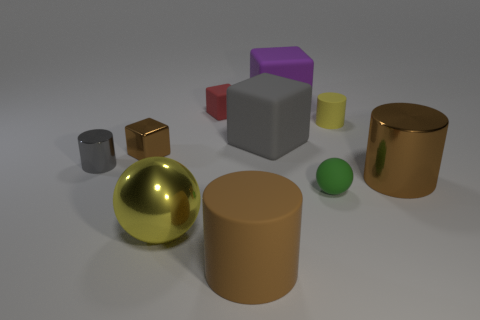Are there more brown shiny blocks right of the large yellow metallic ball than big rubber things behind the yellow matte cylinder?
Offer a very short reply. No. What is the material of the tiny brown thing?
Keep it short and to the point. Metal. There is a brown metal thing to the left of the small cube to the right of the block left of the large yellow metal object; what is its shape?
Keep it short and to the point. Cube. How many other things are the same material as the large purple cube?
Offer a terse response. 5. Are the gray object left of the big matte cylinder and the cylinder that is in front of the brown metallic cylinder made of the same material?
Provide a succinct answer. No. What number of big brown cylinders are both on the left side of the small yellow rubber cylinder and on the right side of the purple matte cube?
Your response must be concise. 0. Are there any green things that have the same shape as the purple rubber thing?
Keep it short and to the point. No. The yellow matte thing that is the same size as the gray cylinder is what shape?
Make the answer very short. Cylinder. Are there an equal number of small matte balls that are left of the yellow metal ball and small gray cylinders in front of the purple block?
Offer a terse response. No. How big is the gray thing that is on the right side of the small cylinder in front of the tiny brown object?
Make the answer very short. Large. 